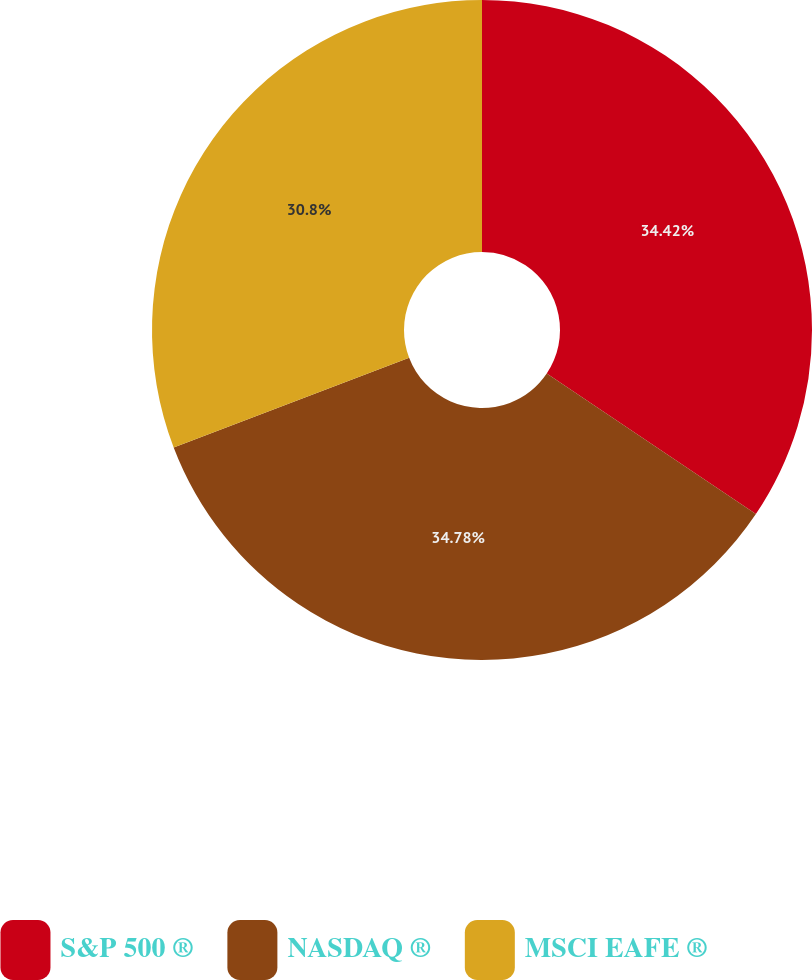Convert chart. <chart><loc_0><loc_0><loc_500><loc_500><pie_chart><fcel>S&P 500 ®<fcel>NASDAQ ®<fcel>MSCI EAFE ®<nl><fcel>34.42%<fcel>34.78%<fcel>30.8%<nl></chart> 